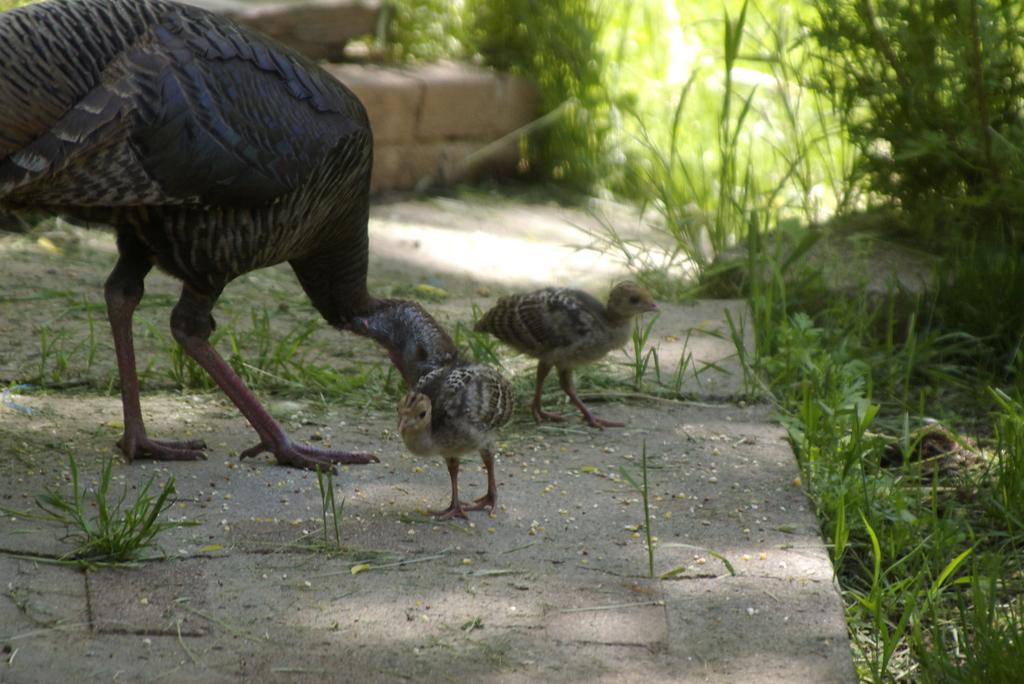What is located in the center of the image? There are birds in the center of the image. What can be seen on the right side of the image? There are plants and grass on the right side of the image. What is visible at the bottom of the image? The ground is visible at the bottom of the image. Can you see a couple kissing in the image? There is no couple or any indication of a kiss in the image; it features birds, plants, grass, and the ground. What type of cemetery is visible in the image? There is no cemetery present in the image; it features birds, plants, grass, and the ground. 